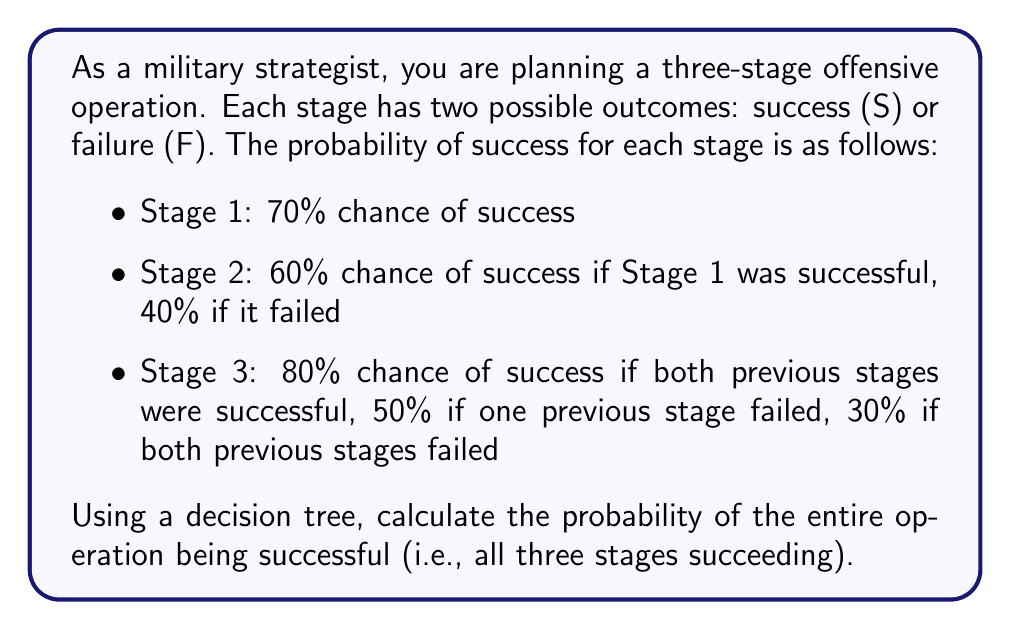Give your solution to this math problem. To solve this problem, we'll use a decision tree and the multiplication rule of probability. Let's break it down step-by-step:

1) First, let's construct the decision tree:

[asy]
unitsize(1cm);

pair A=(0,0), B=(2,1), C=(2,-1), D=(4,1.5), E=(4,0.5), F=(4,-0.5), G=(4,-1.5);
pair H=(6,1.75), I=(6,1.25), J=(6,0.75), K=(6,0.25), L=(6,-0.25), M=(6,-0.75), N=(6,-1.25), O=(6,-1.75);

draw(A--B--D--H);
draw(B--E, D--I, E--J, E--K);
draw(A--C--F--L);
draw(C--G, F--M, G--N, G--O);

label("S 0.7", (A--B), N);
label("F 0.3", (A--C), S);

label("S 0.6", (B--D), N);
label("F 0.4", (B--E), S);
label("S 0.4", (C--F), N);
label("F 0.6", (C--G), S);

label("S 0.8", (D--H), N);
label("F 0.2", (D--I), S);
label("S 0.5", (E--J), N);
label("F 0.5", (E--K), S);
label("S 0.5", (F--L), N);
label("F 0.5", (F--M), S);
label("S 0.3", (G--N), N);
label("F 0.7", (G--O), S);

label("Stage 1", (-1,0));
label("Stage 2", (3,0));
label("Stage 3", (7,0));
[/asy]

2) Now, let's calculate the probability of success for each path:

   Path 1 (SSS): $P(\text{SSS}) = 0.7 \times 0.6 \times 0.8 = 0.336$

3) This is the only path that leads to overall success (all three stages successful).

4) Therefore, the probability of the entire operation being successful is 0.336 or 33.6%.
Answer: The probability of the entire operation being successful (all three stages succeeding) is 0.336 or 33.6%. 